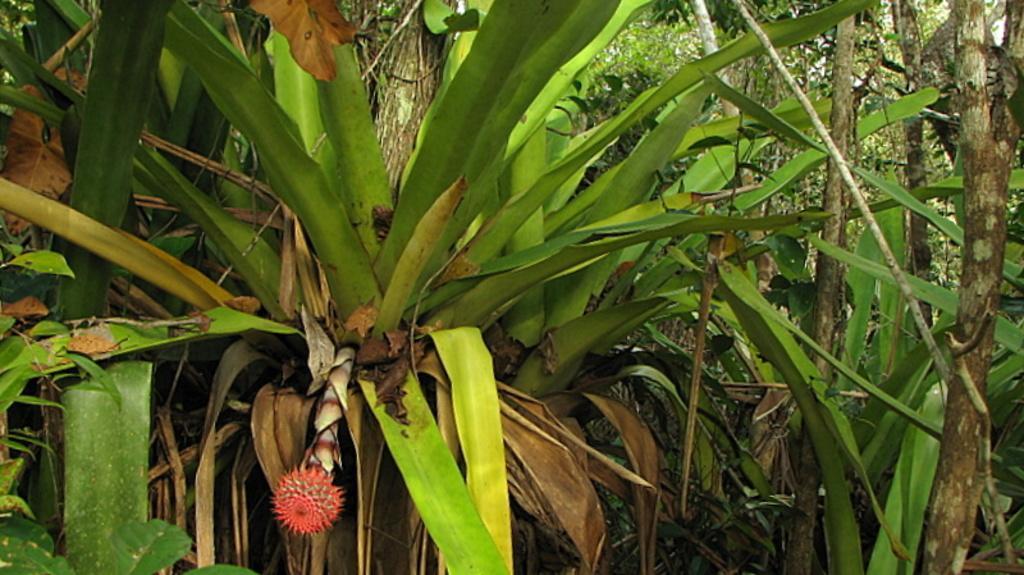Please provide a concise description of this image. Here in this picture we can see plants and trees present all over there and on the left bottom side we can see a flower also present over there. 